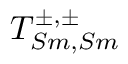<formula> <loc_0><loc_0><loc_500><loc_500>T _ { S m , S m } ^ { \pm , \pm }</formula> 